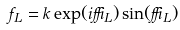Convert formula to latex. <formula><loc_0><loc_0><loc_500><loc_500>f _ { L } = k \exp ( i \delta _ { L } ) \sin ( \delta _ { L } )</formula> 